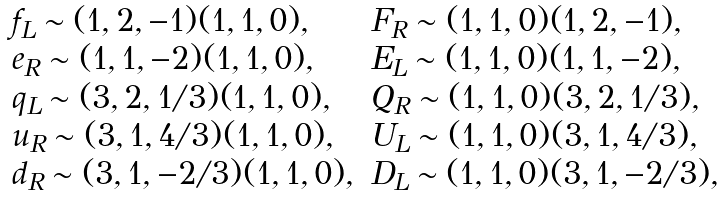Convert formula to latex. <formula><loc_0><loc_0><loc_500><loc_500>\begin{array} { l l } f _ { L } \sim ( 1 , 2 , - 1 ) ( 1 , 1 , 0 ) , & F _ { R } \sim ( 1 , 1 , 0 ) ( 1 , 2 , - 1 ) , \\ e _ { R } \sim ( 1 , 1 , - 2 ) ( 1 , 1 , 0 ) , & E _ { L } \sim ( 1 , 1 , 0 ) ( 1 , 1 , - 2 ) , \\ q _ { L } \sim ( 3 , 2 , 1 / 3 ) ( 1 , 1 , 0 ) , & Q _ { R } \sim ( 1 , 1 , 0 ) ( 3 , 2 , 1 / 3 ) , \\ u _ { R } \sim ( 3 , 1 , 4 / 3 ) ( 1 , 1 , 0 ) , & U _ { L } \sim ( 1 , 1 , 0 ) ( 3 , 1 , 4 / 3 ) , \\ d _ { R } \sim ( 3 , 1 , - 2 / 3 ) ( 1 , 1 , 0 ) , & D _ { L } \sim ( 1 , 1 , 0 ) ( 3 , 1 , - 2 / 3 ) , \end{array}</formula> 